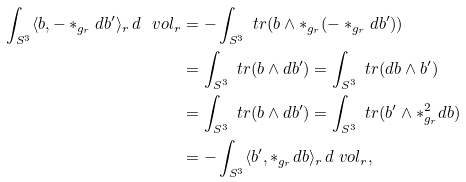Convert formula to latex. <formula><loc_0><loc_0><loc_500><loc_500>\int _ { S ^ { 3 } } \langle b , - * _ { g _ { r } } d b ^ { \prime } \rangle _ { r } \, d \ v o l _ { r } & = - \int _ { S ^ { 3 } } \ t r ( b \wedge * _ { g _ { r } } ( - * _ { g _ { r } } d b ^ { \prime } ) ) \\ & = \int _ { S ^ { 3 } } \ t r ( b \wedge d b ^ { \prime } ) = \int _ { S ^ { 3 } } \ t r ( d b \wedge b ^ { \prime } ) \\ & = \int _ { S ^ { 3 } } \ t r ( b \wedge d b ^ { \prime } ) = \int _ { S ^ { 3 } } \ t r ( b ^ { \prime } \wedge * _ { g _ { r } } ^ { 2 } d b ) \\ & = - \int _ { S ^ { 3 } } \langle b ^ { \prime } , * _ { g _ { r } } d b \rangle _ { r } \, d \ v o l _ { r } ,</formula> 